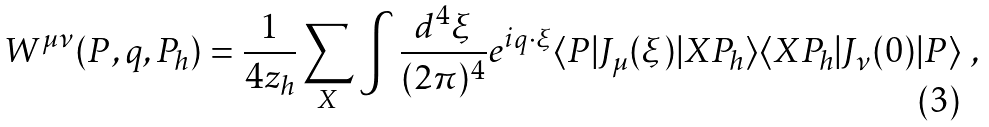Convert formula to latex. <formula><loc_0><loc_0><loc_500><loc_500>W ^ { \mu \nu } ( P , q , P _ { h } ) = \frac { 1 } { 4 z _ { h } } \sum _ { X } \int \frac { d ^ { 4 } \xi } { ( 2 \pi ) ^ { 4 } } e ^ { i q \cdot \xi } \langle P | J _ { \mu } ( \xi ) | X P _ { h } \rangle \langle X P _ { h } | J _ { \nu } ( 0 ) | P \rangle \ ,</formula> 